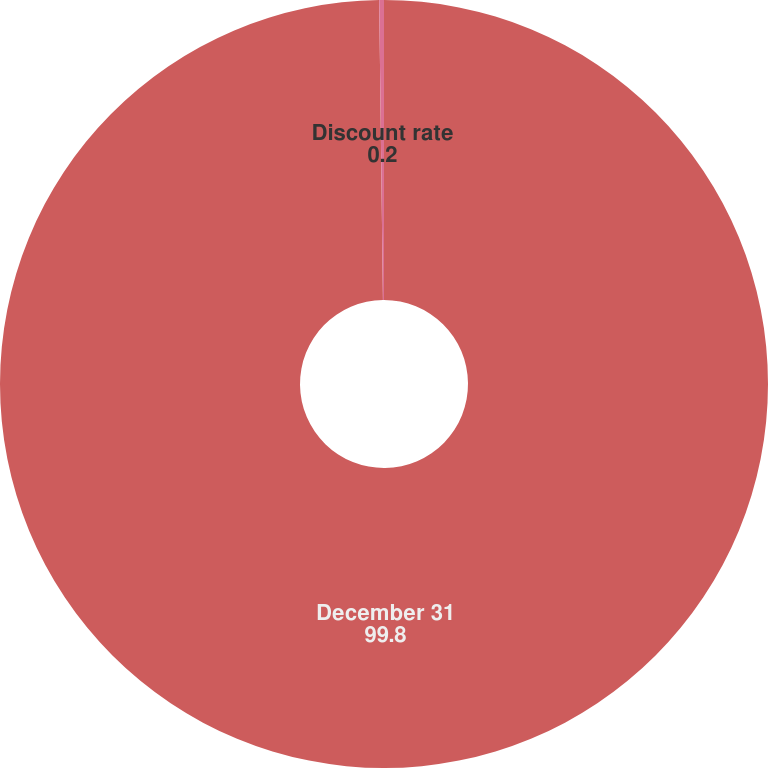<chart> <loc_0><loc_0><loc_500><loc_500><pie_chart><fcel>December 31<fcel>Discount rate<nl><fcel>99.8%<fcel>0.2%<nl></chart> 